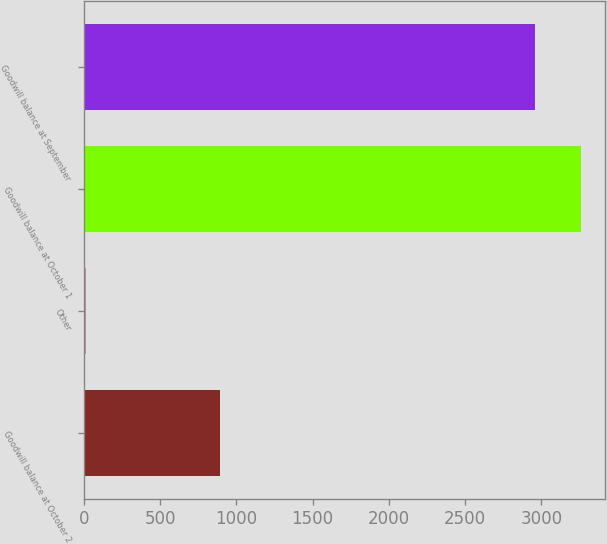Convert chart to OTSL. <chart><loc_0><loc_0><loc_500><loc_500><bar_chart><fcel>Goodwill balance at October 2<fcel>Other<fcel>Goodwill balance at October 1<fcel>Goodwill balance at September<nl><fcel>892.7<fcel>15.9<fcel>3257.13<fcel>2958.4<nl></chart> 